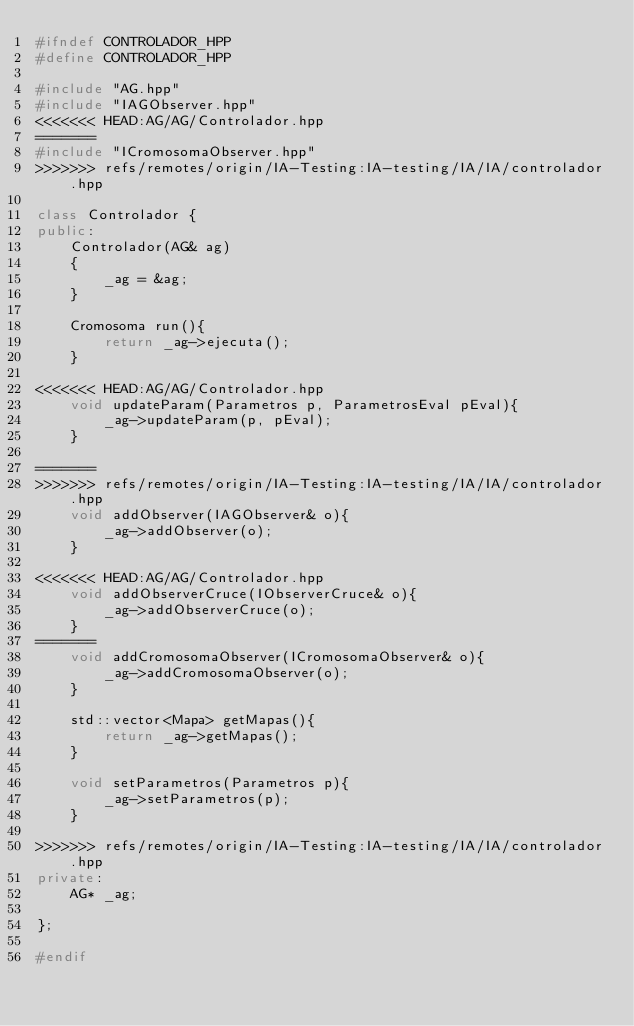Convert code to text. <code><loc_0><loc_0><loc_500><loc_500><_C++_>#ifndef CONTROLADOR_HPP
#define CONTROLADOR_HPP

#include "AG.hpp"
#include "IAGObserver.hpp"
<<<<<<< HEAD:AG/AG/Controlador.hpp
=======
#include "ICromosomaObserver.hpp"
>>>>>>> refs/remotes/origin/IA-Testing:IA-testing/IA/IA/controlador.hpp

class Controlador {
public:
	Controlador(AG& ag)
	{
		_ag = &ag;
	}

	Cromosoma run(){
		return _ag->ejecuta();
	}

<<<<<<< HEAD:AG/AG/Controlador.hpp
	void updateParam(Parametros p, ParametrosEval pEval){
		_ag->updateParam(p, pEval);
	}

=======
>>>>>>> refs/remotes/origin/IA-Testing:IA-testing/IA/IA/controlador.hpp
	void addObserver(IAGObserver& o){
		_ag->addObserver(o);
	}

<<<<<<< HEAD:AG/AG/Controlador.hpp
	void addObserverCruce(IObserverCruce& o){
		_ag->addObserverCruce(o);
	}
=======
	void addCromosomaObserver(ICromosomaObserver& o){
		_ag->addCromosomaObserver(o);
	}

	std::vector<Mapa> getMapas(){
		return _ag->getMapas();
	}

	void setParametros(Parametros p){
		_ag->setParametros(p);
	}

>>>>>>> refs/remotes/origin/IA-Testing:IA-testing/IA/IA/controlador.hpp
private:
	AG* _ag;

};

#endif</code> 